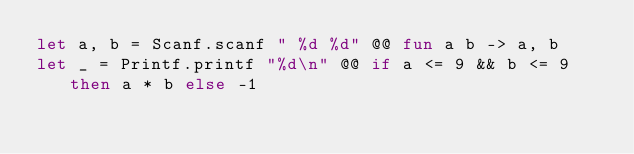Convert code to text. <code><loc_0><loc_0><loc_500><loc_500><_OCaml_>let a, b = Scanf.scanf " %d %d" @@ fun a b -> a, b
let _ = Printf.printf "%d\n" @@ if a <= 9 && b <= 9 then a * b else -1</code> 